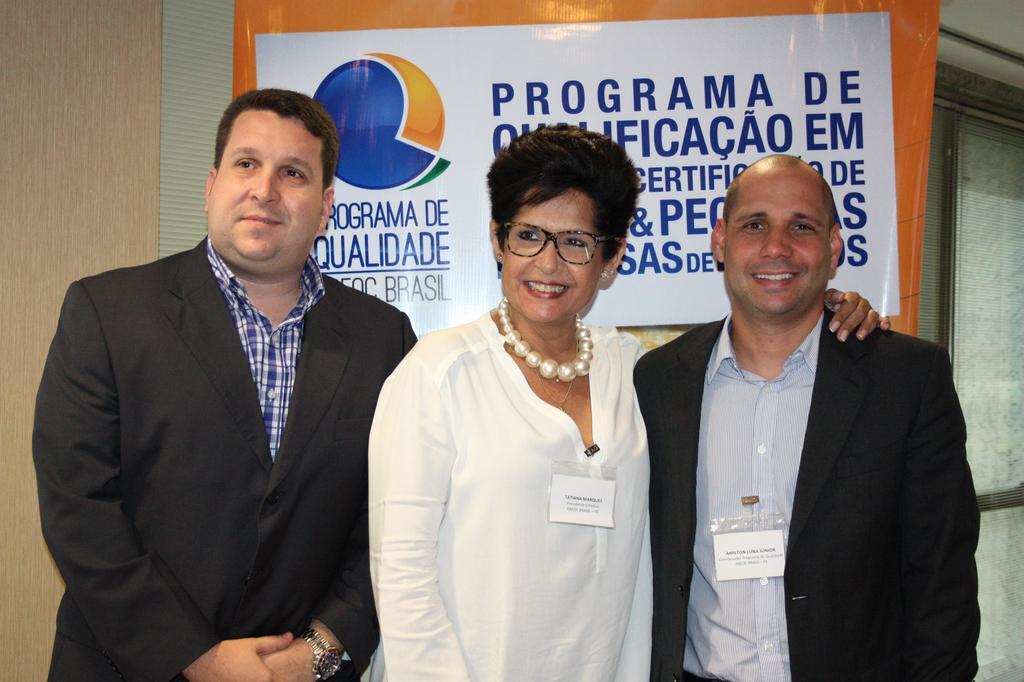In one or two sentences, can you explain what this image depicts? In this image there are two men and a woman standing, in the background there is a wall for that wall there is a banner, on that banner there is some text. 